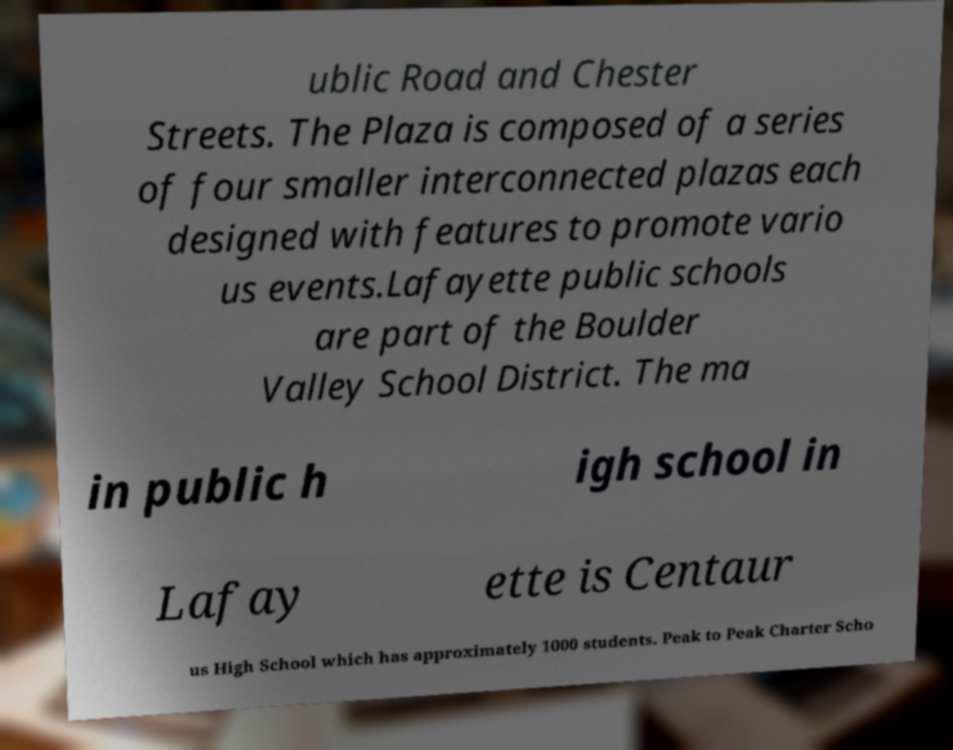There's text embedded in this image that I need extracted. Can you transcribe it verbatim? ublic Road and Chester Streets. The Plaza is composed of a series of four smaller interconnected plazas each designed with features to promote vario us events.Lafayette public schools are part of the Boulder Valley School District. The ma in public h igh school in Lafay ette is Centaur us High School which has approximately 1000 students. Peak to Peak Charter Scho 